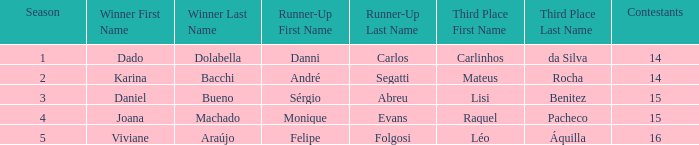When sérgio abreu was the runner-up, how many participants were in the competition? 15.0. Could you parse the entire table? {'header': ['Season', 'Winner First Name', 'Winner Last Name', 'Runner-Up First Name', 'Runner-Up Last Name', 'Third Place First Name', 'Third Place Last Name', 'Contestants'], 'rows': [['1', 'Dado', 'Dolabella', 'Danni', 'Carlos', 'Carlinhos', 'da Silva', '14'], ['2', 'Karina', 'Bacchi', 'André', 'Segatti', 'Mateus', 'Rocha', '14'], ['3', 'Daniel', 'Bueno', 'Sérgio', 'Abreu', 'Lisi', 'Benitez', '15'], ['4', 'Joana', 'Machado', 'Monique', 'Evans', 'Raquel', 'Pacheco', '15'], ['5', 'Viviane', 'Araújo', 'Felipe', 'Folgosi', 'Léo', 'Áquilla', '16']]} 